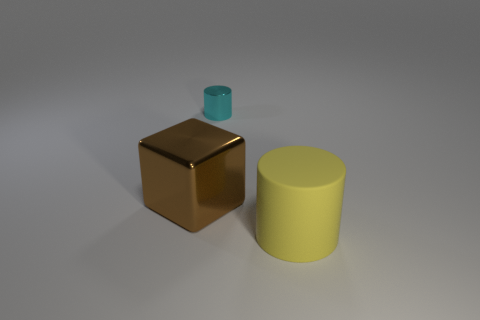Is there any other thing that is made of the same material as the large yellow cylinder?
Make the answer very short. No. How many brown things have the same size as the cyan shiny cylinder?
Your response must be concise. 0. What is the object that is in front of the tiny cyan metal thing and on the right side of the big shiny object made of?
Provide a succinct answer. Rubber. Is the number of gray matte blocks greater than the number of metallic cylinders?
Provide a short and direct response. No. What is the color of the big thing that is on the left side of the object that is in front of the large object to the left of the cyan metal thing?
Provide a short and direct response. Brown. Do the cylinder that is left of the yellow cylinder and the brown block have the same material?
Give a very brief answer. Yes. Are there any cubes that have the same color as the rubber thing?
Your response must be concise. No. Is there a gray sphere?
Provide a short and direct response. No. There is a cylinder that is in front of the cyan cylinder; does it have the same size as the small cyan cylinder?
Give a very brief answer. No. Are there fewer large matte things than metallic things?
Make the answer very short. Yes. 